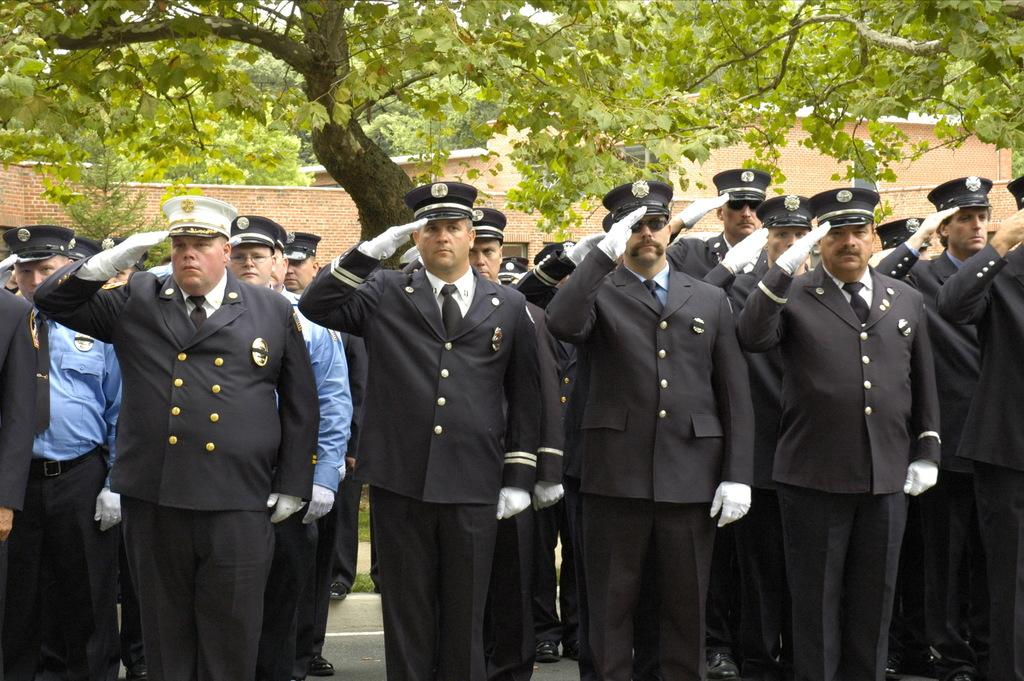What can be seen in the foreground of the image? There are people standing in the foreground of the image. What is visible in the background of the image? There are houses and trees in the background of the image. How much payment is required to enter the houses in the image? There is no indication of payment or entering the houses in the image; it simply shows houses in the background. 